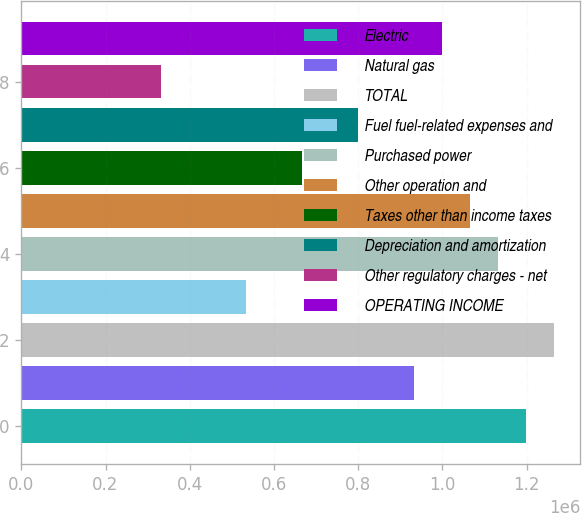<chart> <loc_0><loc_0><loc_500><loc_500><bar_chart><fcel>Electric<fcel>Natural gas<fcel>TOTAL<fcel>Fuel fuel-related expenses and<fcel>Purchased power<fcel>Other operation and<fcel>Taxes other than income taxes<fcel>Depreciation and amortization<fcel>Other regulatory charges - net<fcel>OPERATING INCOME<nl><fcel>1.19763e+06<fcel>931546<fcel>1.26415e+06<fcel>532422<fcel>1.13111e+06<fcel>1.06459e+06<fcel>665463<fcel>798504<fcel>332860<fcel>998066<nl></chart> 